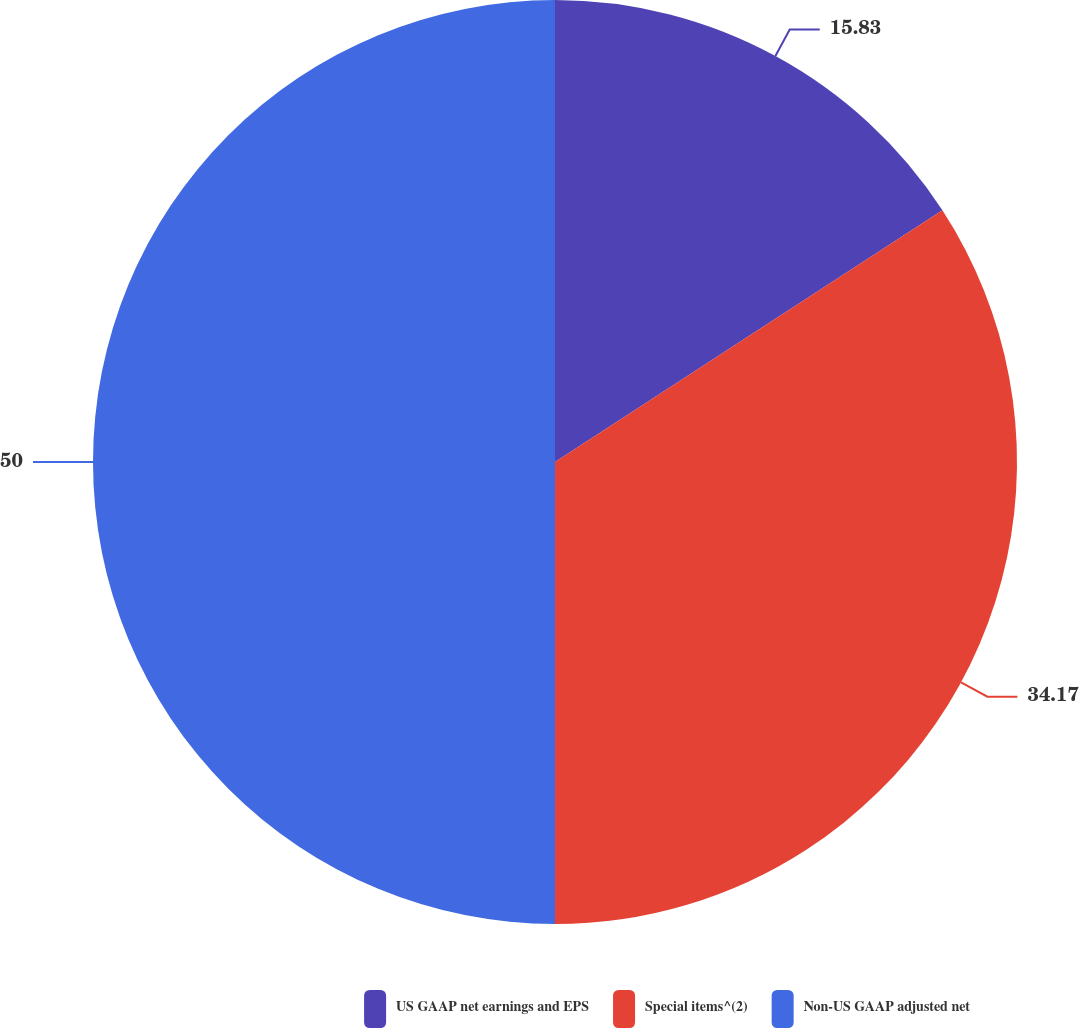Convert chart. <chart><loc_0><loc_0><loc_500><loc_500><pie_chart><fcel>US GAAP net earnings and EPS<fcel>Special items^(2)<fcel>Non-US GAAP adjusted net<nl><fcel>15.83%<fcel>34.17%<fcel>50.0%<nl></chart> 